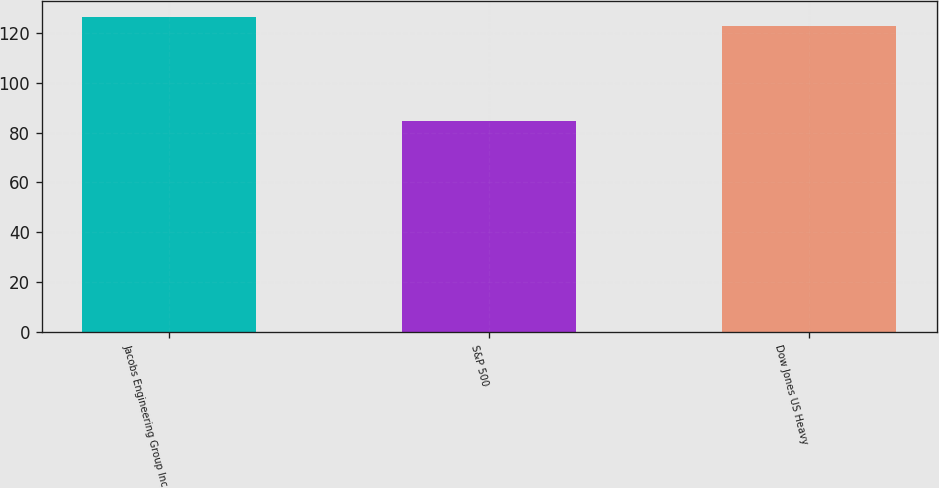<chart> <loc_0><loc_0><loc_500><loc_500><bar_chart><fcel>Jacobs Engineering Group Inc<fcel>S&P 500<fcel>Dow Jones US Heavy<nl><fcel>126.58<fcel>84.58<fcel>122.74<nl></chart> 